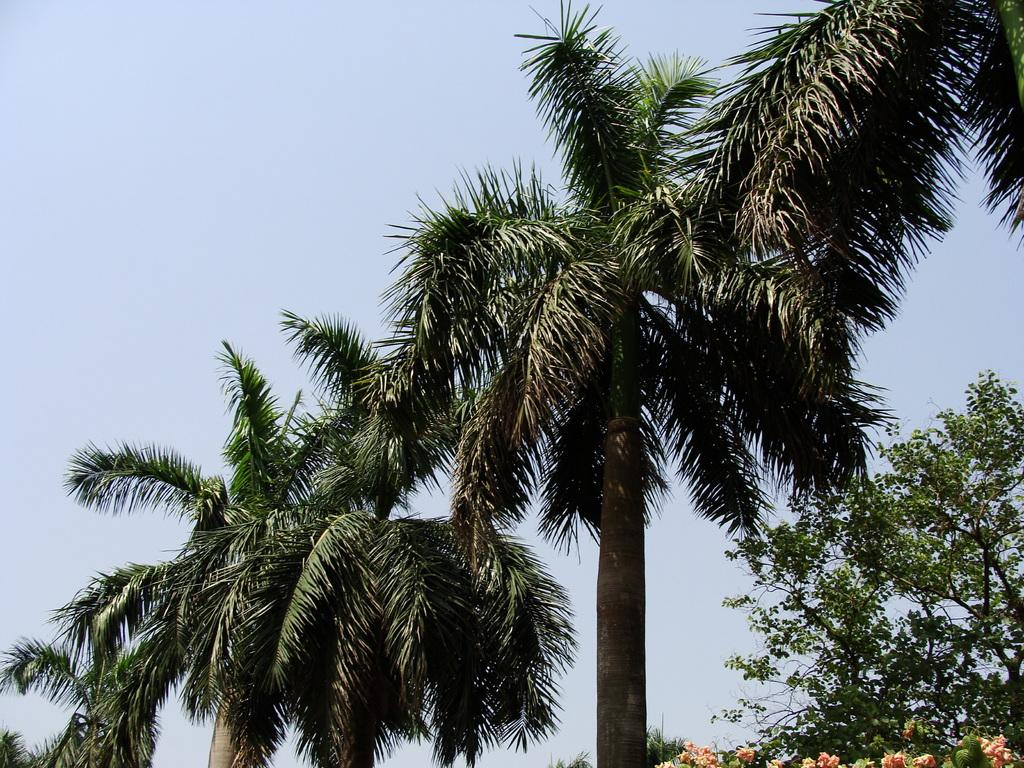What type of plants can be seen in the image? There are flowers in the image. What other natural elements are present in the image? There are trees in the image. What is visible in the background of the image? The sky is visible in the background of the image. What type of poison is being used to control the growth of the flowers in the image? There is no indication in the image that any poison is being used to control the growth of the flowers. 